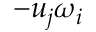Convert formula to latex. <formula><loc_0><loc_0><loc_500><loc_500>- u _ { j } \omega _ { i }</formula> 